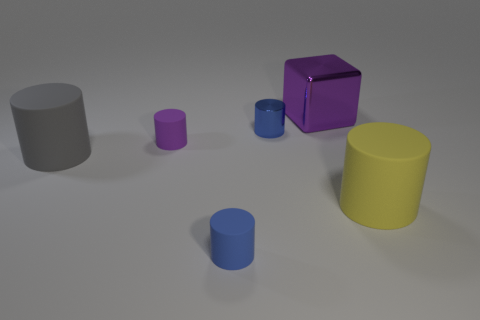Subtract all purple cylinders. How many cylinders are left? 4 Subtract all blue shiny cylinders. How many cylinders are left? 4 Subtract all red cylinders. Subtract all brown balls. How many cylinders are left? 5 Add 4 big brown spheres. How many objects exist? 10 Subtract all cubes. How many objects are left? 5 Add 4 large green blocks. How many large green blocks exist? 4 Subtract 0 red cubes. How many objects are left? 6 Subtract all matte objects. Subtract all large cubes. How many objects are left? 1 Add 2 large yellow rubber cylinders. How many large yellow rubber cylinders are left? 3 